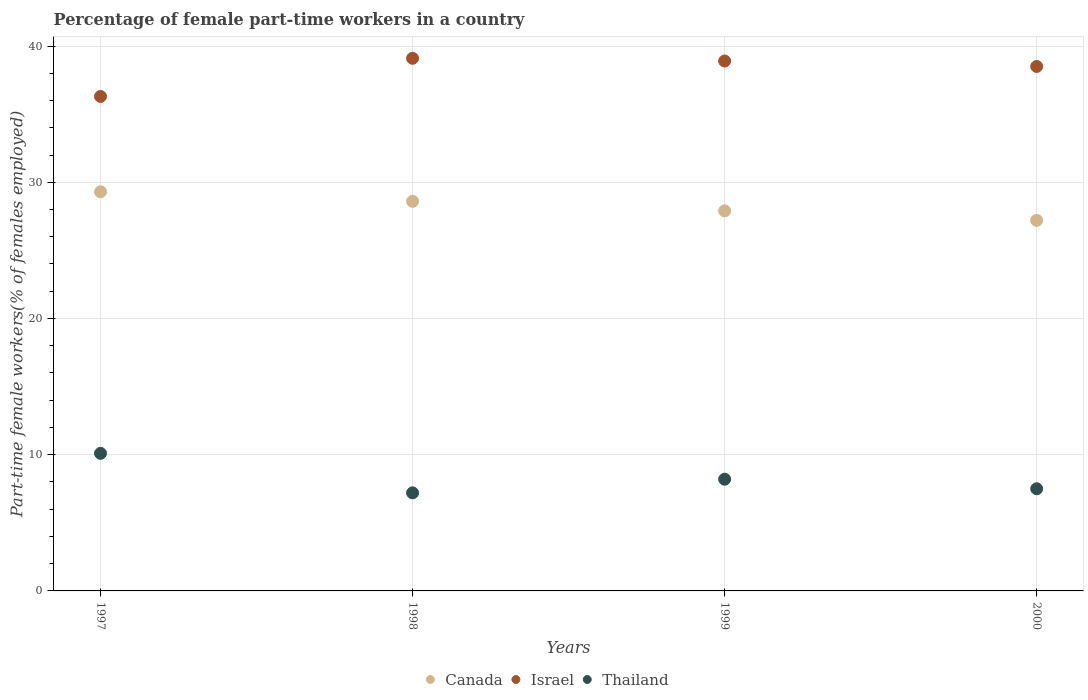How many different coloured dotlines are there?
Your answer should be very brief. 3. What is the percentage of female part-time workers in Canada in 1998?
Provide a short and direct response. 28.6. Across all years, what is the maximum percentage of female part-time workers in Israel?
Provide a short and direct response. 39.1. Across all years, what is the minimum percentage of female part-time workers in Thailand?
Ensure brevity in your answer.  7.2. In which year was the percentage of female part-time workers in Canada minimum?
Provide a short and direct response. 2000. What is the total percentage of female part-time workers in Thailand in the graph?
Ensure brevity in your answer.  33. What is the difference between the percentage of female part-time workers in Israel in 1999 and that in 2000?
Your answer should be very brief. 0.4. What is the difference between the percentage of female part-time workers in Israel in 1997 and the percentage of female part-time workers in Canada in 2000?
Keep it short and to the point. 9.1. What is the average percentage of female part-time workers in Thailand per year?
Keep it short and to the point. 8.25. In the year 1999, what is the difference between the percentage of female part-time workers in Canada and percentage of female part-time workers in Israel?
Keep it short and to the point. -11. What is the ratio of the percentage of female part-time workers in Israel in 1998 to that in 1999?
Offer a terse response. 1.01. What is the difference between the highest and the second highest percentage of female part-time workers in Thailand?
Ensure brevity in your answer.  1.9. What is the difference between the highest and the lowest percentage of female part-time workers in Thailand?
Make the answer very short. 2.9. Is the sum of the percentage of female part-time workers in Thailand in 1997 and 1999 greater than the maximum percentage of female part-time workers in Canada across all years?
Offer a terse response. No. Is it the case that in every year, the sum of the percentage of female part-time workers in Israel and percentage of female part-time workers in Thailand  is greater than the percentage of female part-time workers in Canada?
Give a very brief answer. Yes. Is the percentage of female part-time workers in Thailand strictly greater than the percentage of female part-time workers in Canada over the years?
Provide a short and direct response. No. Is the percentage of female part-time workers in Israel strictly less than the percentage of female part-time workers in Canada over the years?
Provide a short and direct response. No. How many years are there in the graph?
Make the answer very short. 4. What is the difference between two consecutive major ticks on the Y-axis?
Your response must be concise. 10. How many legend labels are there?
Offer a very short reply. 3. What is the title of the graph?
Provide a short and direct response. Percentage of female part-time workers in a country. Does "Puerto Rico" appear as one of the legend labels in the graph?
Your answer should be compact. No. What is the label or title of the Y-axis?
Offer a very short reply. Part-time female workers(% of females employed). What is the Part-time female workers(% of females employed) of Canada in 1997?
Your answer should be very brief. 29.3. What is the Part-time female workers(% of females employed) of Israel in 1997?
Your response must be concise. 36.3. What is the Part-time female workers(% of females employed) of Thailand in 1997?
Your answer should be compact. 10.1. What is the Part-time female workers(% of females employed) in Canada in 1998?
Keep it short and to the point. 28.6. What is the Part-time female workers(% of females employed) in Israel in 1998?
Give a very brief answer. 39.1. What is the Part-time female workers(% of females employed) of Thailand in 1998?
Your answer should be compact. 7.2. What is the Part-time female workers(% of females employed) of Canada in 1999?
Keep it short and to the point. 27.9. What is the Part-time female workers(% of females employed) of Israel in 1999?
Offer a very short reply. 38.9. What is the Part-time female workers(% of females employed) of Thailand in 1999?
Offer a very short reply. 8.2. What is the Part-time female workers(% of females employed) in Canada in 2000?
Ensure brevity in your answer.  27.2. What is the Part-time female workers(% of females employed) in Israel in 2000?
Ensure brevity in your answer.  38.5. Across all years, what is the maximum Part-time female workers(% of females employed) in Canada?
Make the answer very short. 29.3. Across all years, what is the maximum Part-time female workers(% of females employed) of Israel?
Your answer should be very brief. 39.1. Across all years, what is the maximum Part-time female workers(% of females employed) of Thailand?
Offer a very short reply. 10.1. Across all years, what is the minimum Part-time female workers(% of females employed) of Canada?
Give a very brief answer. 27.2. Across all years, what is the minimum Part-time female workers(% of females employed) of Israel?
Your answer should be compact. 36.3. Across all years, what is the minimum Part-time female workers(% of females employed) in Thailand?
Offer a very short reply. 7.2. What is the total Part-time female workers(% of females employed) in Canada in the graph?
Make the answer very short. 113. What is the total Part-time female workers(% of females employed) of Israel in the graph?
Your answer should be very brief. 152.8. What is the difference between the Part-time female workers(% of females employed) of Thailand in 1997 and that in 1999?
Provide a succinct answer. 1.9. What is the difference between the Part-time female workers(% of females employed) in Canada in 1997 and that in 2000?
Give a very brief answer. 2.1. What is the difference between the Part-time female workers(% of females employed) in Israel in 1997 and that in 2000?
Make the answer very short. -2.2. What is the difference between the Part-time female workers(% of females employed) of Thailand in 1997 and that in 2000?
Your answer should be very brief. 2.6. What is the difference between the Part-time female workers(% of females employed) of Canada in 1998 and that in 1999?
Your answer should be compact. 0.7. What is the difference between the Part-time female workers(% of females employed) in Thailand in 1998 and that in 1999?
Give a very brief answer. -1. What is the difference between the Part-time female workers(% of females employed) in Canada in 1999 and that in 2000?
Give a very brief answer. 0.7. What is the difference between the Part-time female workers(% of females employed) in Israel in 1999 and that in 2000?
Give a very brief answer. 0.4. What is the difference between the Part-time female workers(% of females employed) in Canada in 1997 and the Part-time female workers(% of females employed) in Thailand in 1998?
Offer a terse response. 22.1. What is the difference between the Part-time female workers(% of females employed) in Israel in 1997 and the Part-time female workers(% of females employed) in Thailand in 1998?
Keep it short and to the point. 29.1. What is the difference between the Part-time female workers(% of females employed) of Canada in 1997 and the Part-time female workers(% of females employed) of Thailand in 1999?
Your answer should be compact. 21.1. What is the difference between the Part-time female workers(% of females employed) of Israel in 1997 and the Part-time female workers(% of females employed) of Thailand in 1999?
Provide a succinct answer. 28.1. What is the difference between the Part-time female workers(% of females employed) of Canada in 1997 and the Part-time female workers(% of females employed) of Israel in 2000?
Give a very brief answer. -9.2. What is the difference between the Part-time female workers(% of females employed) in Canada in 1997 and the Part-time female workers(% of females employed) in Thailand in 2000?
Offer a terse response. 21.8. What is the difference between the Part-time female workers(% of females employed) in Israel in 1997 and the Part-time female workers(% of females employed) in Thailand in 2000?
Provide a short and direct response. 28.8. What is the difference between the Part-time female workers(% of females employed) of Canada in 1998 and the Part-time female workers(% of females employed) of Thailand in 1999?
Provide a succinct answer. 20.4. What is the difference between the Part-time female workers(% of females employed) of Israel in 1998 and the Part-time female workers(% of females employed) of Thailand in 1999?
Offer a terse response. 30.9. What is the difference between the Part-time female workers(% of females employed) of Canada in 1998 and the Part-time female workers(% of females employed) of Israel in 2000?
Provide a short and direct response. -9.9. What is the difference between the Part-time female workers(% of females employed) of Canada in 1998 and the Part-time female workers(% of females employed) of Thailand in 2000?
Give a very brief answer. 21.1. What is the difference between the Part-time female workers(% of females employed) of Israel in 1998 and the Part-time female workers(% of females employed) of Thailand in 2000?
Your answer should be very brief. 31.6. What is the difference between the Part-time female workers(% of females employed) in Canada in 1999 and the Part-time female workers(% of females employed) in Israel in 2000?
Provide a short and direct response. -10.6. What is the difference between the Part-time female workers(% of females employed) in Canada in 1999 and the Part-time female workers(% of females employed) in Thailand in 2000?
Keep it short and to the point. 20.4. What is the difference between the Part-time female workers(% of females employed) in Israel in 1999 and the Part-time female workers(% of females employed) in Thailand in 2000?
Offer a very short reply. 31.4. What is the average Part-time female workers(% of females employed) in Canada per year?
Make the answer very short. 28.25. What is the average Part-time female workers(% of females employed) in Israel per year?
Keep it short and to the point. 38.2. What is the average Part-time female workers(% of females employed) in Thailand per year?
Provide a short and direct response. 8.25. In the year 1997, what is the difference between the Part-time female workers(% of females employed) in Canada and Part-time female workers(% of females employed) in Israel?
Offer a terse response. -7. In the year 1997, what is the difference between the Part-time female workers(% of females employed) in Canada and Part-time female workers(% of females employed) in Thailand?
Your answer should be very brief. 19.2. In the year 1997, what is the difference between the Part-time female workers(% of females employed) of Israel and Part-time female workers(% of females employed) of Thailand?
Ensure brevity in your answer.  26.2. In the year 1998, what is the difference between the Part-time female workers(% of females employed) of Canada and Part-time female workers(% of females employed) of Thailand?
Your answer should be compact. 21.4. In the year 1998, what is the difference between the Part-time female workers(% of females employed) of Israel and Part-time female workers(% of females employed) of Thailand?
Keep it short and to the point. 31.9. In the year 1999, what is the difference between the Part-time female workers(% of females employed) in Canada and Part-time female workers(% of females employed) in Thailand?
Give a very brief answer. 19.7. In the year 1999, what is the difference between the Part-time female workers(% of females employed) in Israel and Part-time female workers(% of females employed) in Thailand?
Ensure brevity in your answer.  30.7. In the year 2000, what is the difference between the Part-time female workers(% of females employed) in Canada and Part-time female workers(% of females employed) in Israel?
Ensure brevity in your answer.  -11.3. In the year 2000, what is the difference between the Part-time female workers(% of females employed) of Canada and Part-time female workers(% of females employed) of Thailand?
Make the answer very short. 19.7. In the year 2000, what is the difference between the Part-time female workers(% of females employed) of Israel and Part-time female workers(% of females employed) of Thailand?
Offer a very short reply. 31. What is the ratio of the Part-time female workers(% of females employed) of Canada in 1997 to that in 1998?
Offer a terse response. 1.02. What is the ratio of the Part-time female workers(% of females employed) in Israel in 1997 to that in 1998?
Offer a very short reply. 0.93. What is the ratio of the Part-time female workers(% of females employed) in Thailand in 1997 to that in 1998?
Provide a succinct answer. 1.4. What is the ratio of the Part-time female workers(% of females employed) of Canada in 1997 to that in 1999?
Ensure brevity in your answer.  1.05. What is the ratio of the Part-time female workers(% of females employed) in Israel in 1997 to that in 1999?
Offer a very short reply. 0.93. What is the ratio of the Part-time female workers(% of females employed) in Thailand in 1997 to that in 1999?
Keep it short and to the point. 1.23. What is the ratio of the Part-time female workers(% of females employed) of Canada in 1997 to that in 2000?
Keep it short and to the point. 1.08. What is the ratio of the Part-time female workers(% of females employed) in Israel in 1997 to that in 2000?
Make the answer very short. 0.94. What is the ratio of the Part-time female workers(% of females employed) of Thailand in 1997 to that in 2000?
Provide a short and direct response. 1.35. What is the ratio of the Part-time female workers(% of females employed) in Canada in 1998 to that in 1999?
Your response must be concise. 1.03. What is the ratio of the Part-time female workers(% of females employed) in Israel in 1998 to that in 1999?
Give a very brief answer. 1.01. What is the ratio of the Part-time female workers(% of females employed) in Thailand in 1998 to that in 1999?
Your response must be concise. 0.88. What is the ratio of the Part-time female workers(% of females employed) in Canada in 1998 to that in 2000?
Keep it short and to the point. 1.05. What is the ratio of the Part-time female workers(% of females employed) in Israel in 1998 to that in 2000?
Ensure brevity in your answer.  1.02. What is the ratio of the Part-time female workers(% of females employed) of Thailand in 1998 to that in 2000?
Your answer should be very brief. 0.96. What is the ratio of the Part-time female workers(% of females employed) in Canada in 1999 to that in 2000?
Offer a very short reply. 1.03. What is the ratio of the Part-time female workers(% of females employed) in Israel in 1999 to that in 2000?
Your response must be concise. 1.01. What is the ratio of the Part-time female workers(% of females employed) of Thailand in 1999 to that in 2000?
Your answer should be very brief. 1.09. What is the difference between the highest and the second highest Part-time female workers(% of females employed) of Canada?
Provide a succinct answer. 0.7. What is the difference between the highest and the second highest Part-time female workers(% of females employed) in Israel?
Provide a short and direct response. 0.2. What is the difference between the highest and the lowest Part-time female workers(% of females employed) in Thailand?
Your response must be concise. 2.9. 